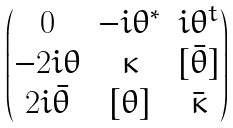<formula> <loc_0><loc_0><loc_500><loc_500>\begin{pmatrix} 0 & - i \theta ^ { * } & i \theta ^ { t } \\ - 2 i \theta & \kappa & [ \bar { \theta } ] \\ 2 i \bar { \theta } & [ \theta ] & \bar { \kappa } \end{pmatrix}</formula> 